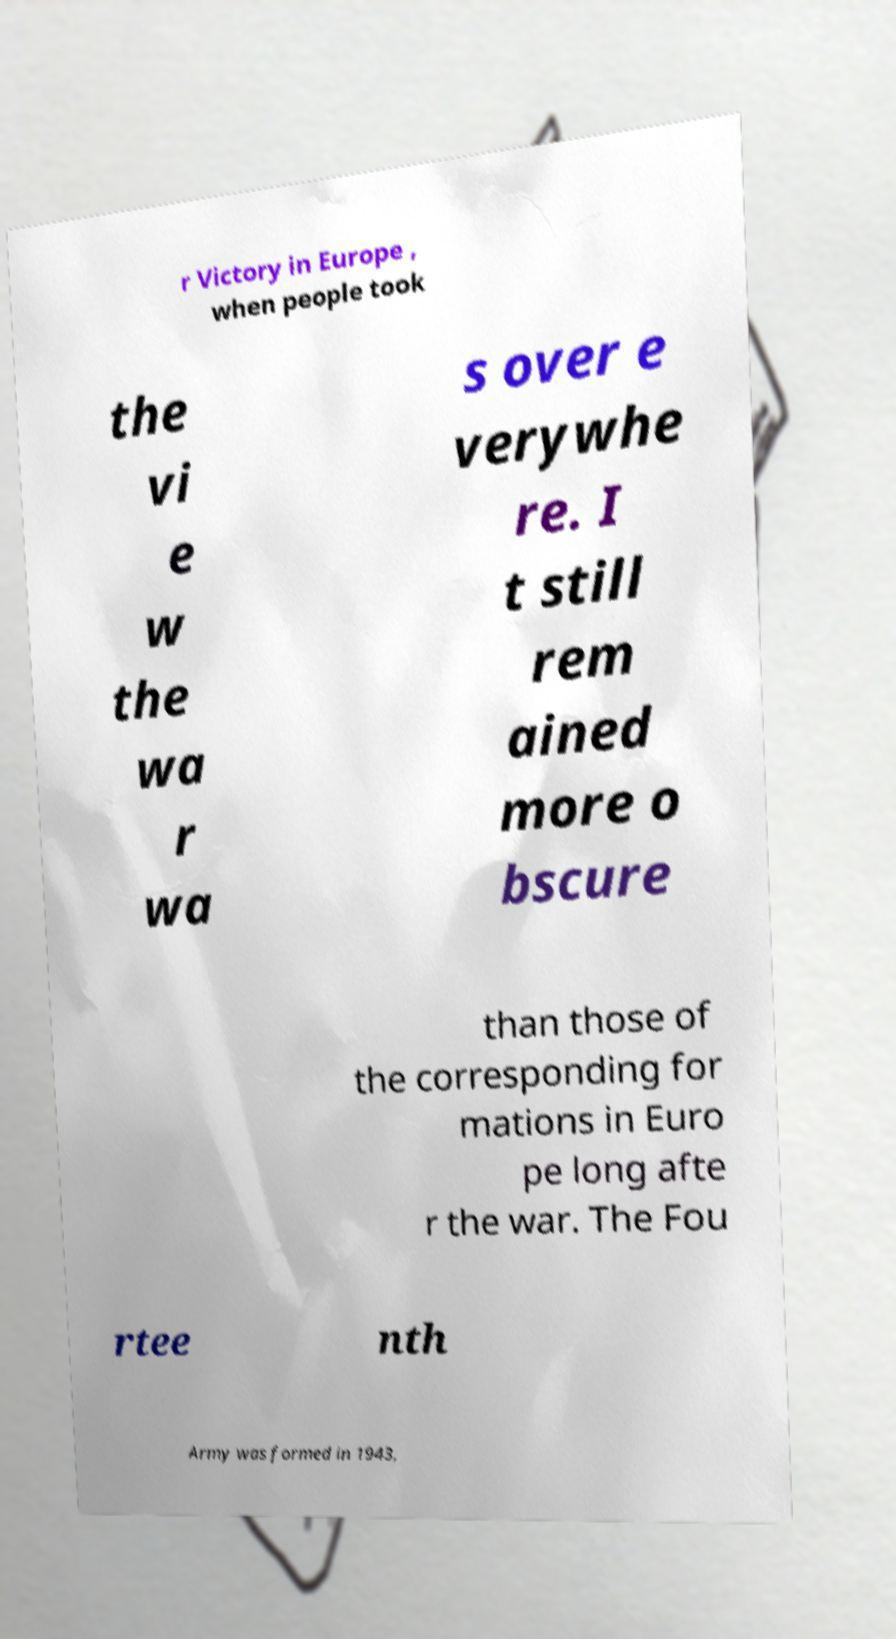Could you assist in decoding the text presented in this image and type it out clearly? r Victory in Europe , when people took the vi e w the wa r wa s over e verywhe re. I t still rem ained more o bscure than those of the corresponding for mations in Euro pe long afte r the war. The Fou rtee nth Army was formed in 1943, 